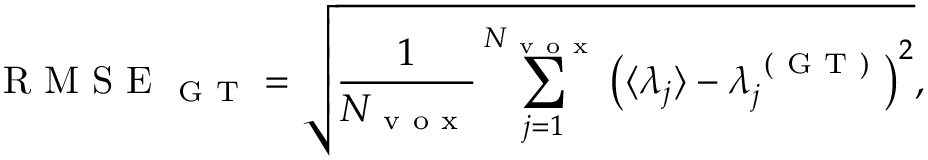<formula> <loc_0><loc_0><loc_500><loc_500>R M S E _ { G T } = \sqrt { \frac { 1 } { N _ { v o x } } \sum _ { j = 1 } ^ { N _ { v o x } } \left ( \langle \lambda _ { j } \rangle - \lambda _ { j } ^ { ( G T ) } \right ) ^ { 2 } } ,</formula> 